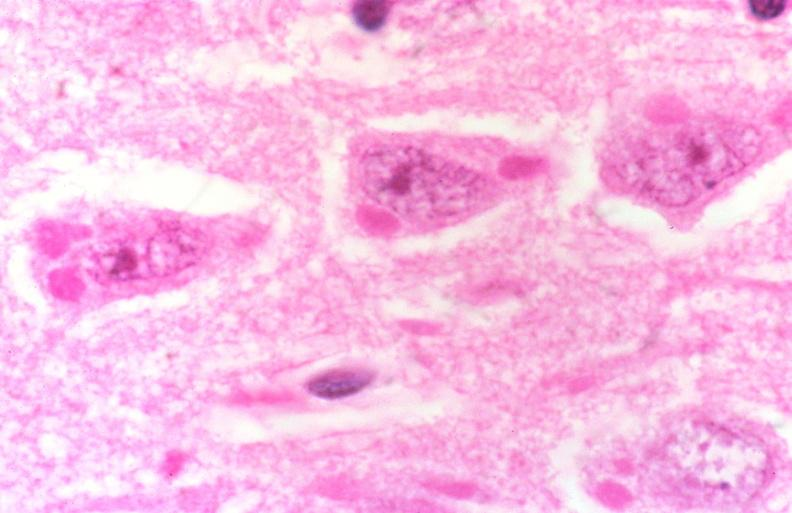s nervous present?
Answer the question using a single word or phrase. Yes 